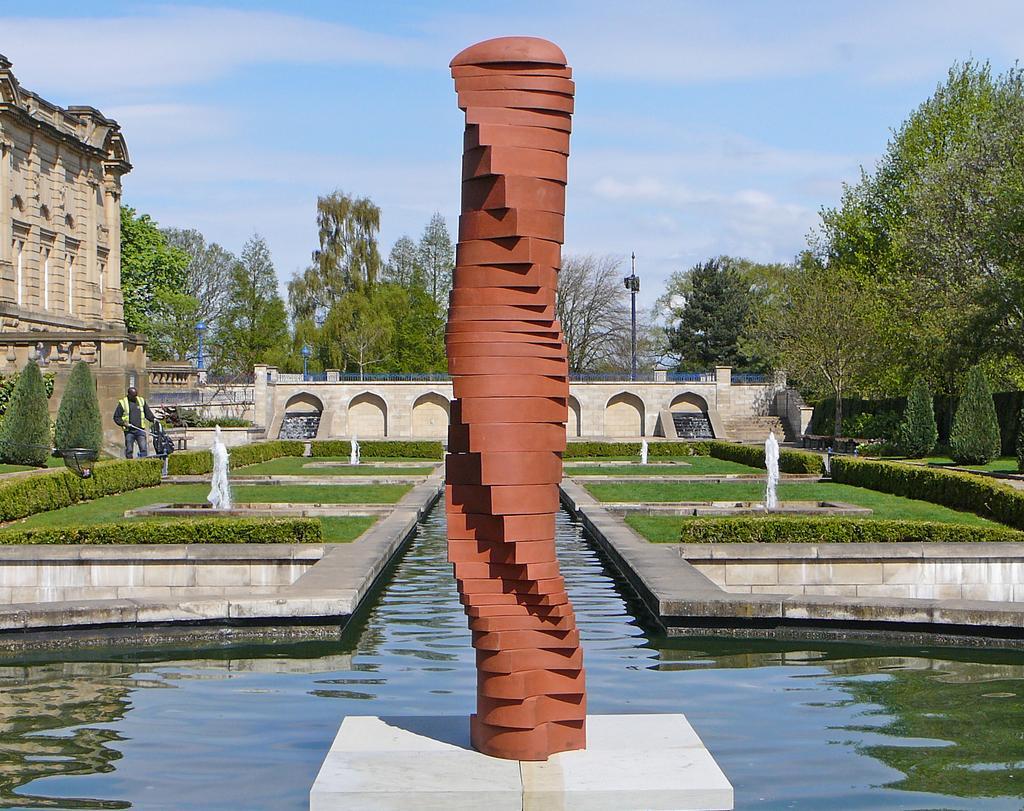Describe this image in one or two sentences. At the center of the image there is a rock structure. Around the rock structure, there are water and fountain with trees and plants. On the left side there is a person standing and there is a building. In the background there are trees and a sky. 